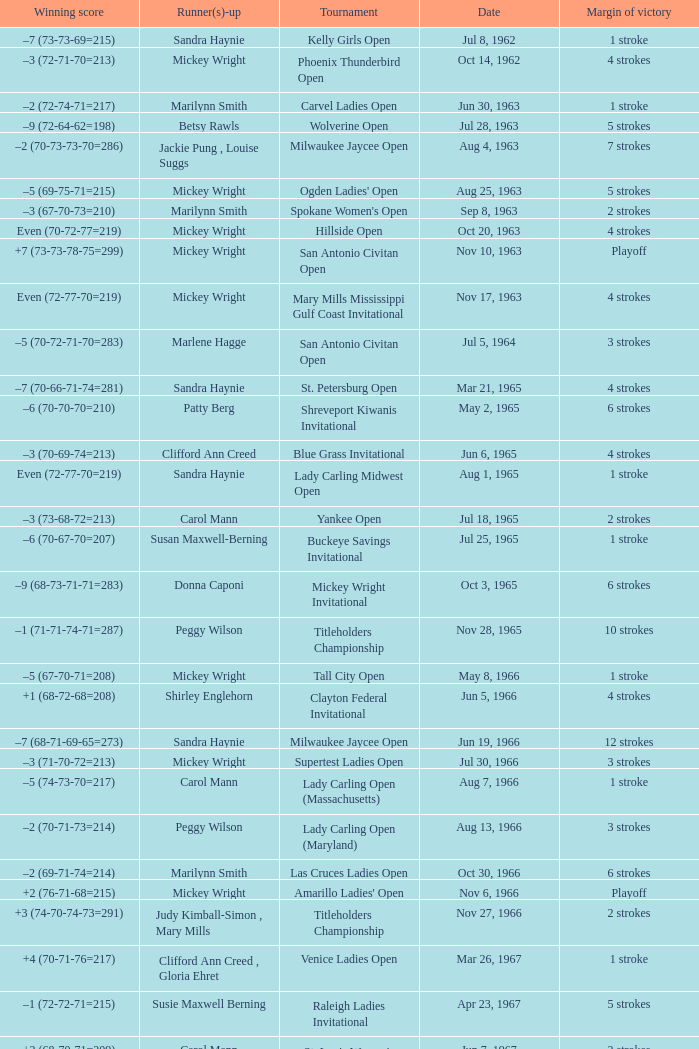What was the margin of victory on Apr 23, 1967? 5 strokes. 